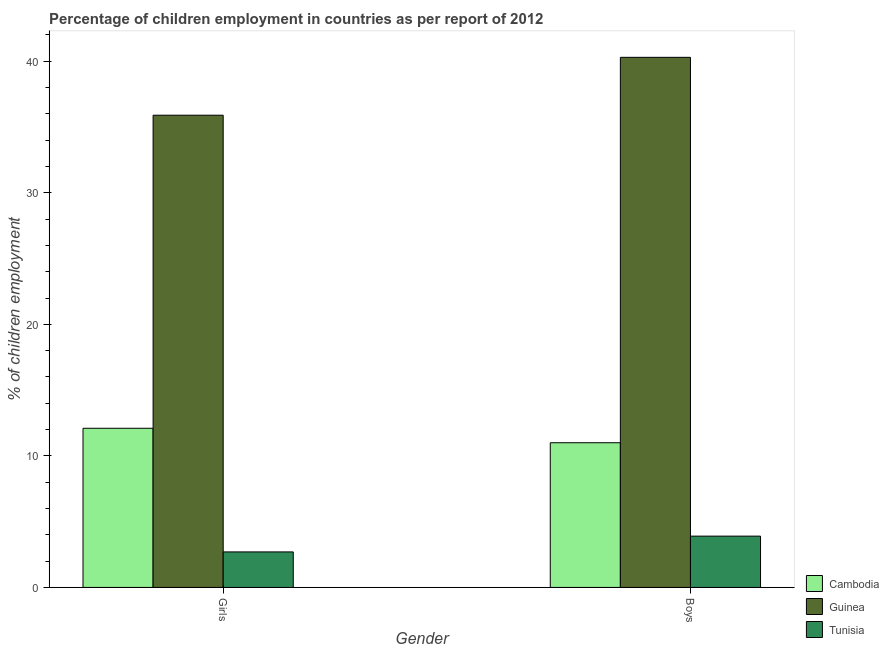Are the number of bars on each tick of the X-axis equal?
Your response must be concise. Yes. What is the label of the 2nd group of bars from the left?
Provide a short and direct response. Boys. What is the percentage of employed girls in Guinea?
Your answer should be compact. 35.9. Across all countries, what is the maximum percentage of employed girls?
Give a very brief answer. 35.9. Across all countries, what is the minimum percentage of employed boys?
Make the answer very short. 3.9. In which country was the percentage of employed girls maximum?
Give a very brief answer. Guinea. In which country was the percentage of employed boys minimum?
Your answer should be compact. Tunisia. What is the total percentage of employed girls in the graph?
Your response must be concise. 50.7. What is the difference between the percentage of employed girls in Cambodia and that in Guinea?
Keep it short and to the point. -23.8. What is the difference between the percentage of employed girls in Cambodia and the percentage of employed boys in Guinea?
Ensure brevity in your answer.  -28.2. What is the difference between the percentage of employed girls and percentage of employed boys in Tunisia?
Provide a short and direct response. -1.2. In how many countries, is the percentage of employed girls greater than 10 %?
Provide a short and direct response. 2. What is the ratio of the percentage of employed girls in Cambodia to that in Guinea?
Offer a terse response. 0.34. Is the percentage of employed boys in Guinea less than that in Tunisia?
Offer a terse response. No. What does the 1st bar from the left in Girls represents?
Your answer should be very brief. Cambodia. What does the 3rd bar from the right in Girls represents?
Your response must be concise. Cambodia. Are all the bars in the graph horizontal?
Provide a succinct answer. No. How many countries are there in the graph?
Provide a short and direct response. 3. What is the difference between two consecutive major ticks on the Y-axis?
Your answer should be very brief. 10. Are the values on the major ticks of Y-axis written in scientific E-notation?
Offer a very short reply. No. Does the graph contain any zero values?
Your response must be concise. No. How are the legend labels stacked?
Ensure brevity in your answer.  Vertical. What is the title of the graph?
Provide a short and direct response. Percentage of children employment in countries as per report of 2012. What is the label or title of the Y-axis?
Provide a short and direct response. % of children employment. What is the % of children employment of Cambodia in Girls?
Offer a very short reply. 12.1. What is the % of children employment in Guinea in Girls?
Give a very brief answer. 35.9. What is the % of children employment in Cambodia in Boys?
Offer a terse response. 11. What is the % of children employment of Guinea in Boys?
Your answer should be very brief. 40.3. What is the % of children employment of Tunisia in Boys?
Your answer should be compact. 3.9. Across all Gender, what is the maximum % of children employment of Guinea?
Make the answer very short. 40.3. Across all Gender, what is the minimum % of children employment of Cambodia?
Ensure brevity in your answer.  11. Across all Gender, what is the minimum % of children employment of Guinea?
Give a very brief answer. 35.9. Across all Gender, what is the minimum % of children employment of Tunisia?
Offer a terse response. 2.7. What is the total % of children employment in Cambodia in the graph?
Provide a succinct answer. 23.1. What is the total % of children employment in Guinea in the graph?
Your answer should be very brief. 76.2. What is the total % of children employment in Tunisia in the graph?
Provide a short and direct response. 6.6. What is the difference between the % of children employment of Cambodia in Girls and that in Boys?
Your answer should be compact. 1.1. What is the difference between the % of children employment of Tunisia in Girls and that in Boys?
Your answer should be compact. -1.2. What is the difference between the % of children employment of Cambodia in Girls and the % of children employment of Guinea in Boys?
Keep it short and to the point. -28.2. What is the average % of children employment of Cambodia per Gender?
Provide a succinct answer. 11.55. What is the average % of children employment in Guinea per Gender?
Your response must be concise. 38.1. What is the difference between the % of children employment in Cambodia and % of children employment in Guinea in Girls?
Your answer should be compact. -23.8. What is the difference between the % of children employment in Cambodia and % of children employment in Tunisia in Girls?
Provide a succinct answer. 9.4. What is the difference between the % of children employment of Guinea and % of children employment of Tunisia in Girls?
Your response must be concise. 33.2. What is the difference between the % of children employment of Cambodia and % of children employment of Guinea in Boys?
Give a very brief answer. -29.3. What is the difference between the % of children employment in Guinea and % of children employment in Tunisia in Boys?
Offer a very short reply. 36.4. What is the ratio of the % of children employment in Guinea in Girls to that in Boys?
Your response must be concise. 0.89. What is the ratio of the % of children employment of Tunisia in Girls to that in Boys?
Make the answer very short. 0.69. What is the difference between the highest and the second highest % of children employment of Cambodia?
Keep it short and to the point. 1.1. What is the difference between the highest and the lowest % of children employment of Cambodia?
Keep it short and to the point. 1.1. What is the difference between the highest and the lowest % of children employment in Tunisia?
Your answer should be compact. 1.2. 